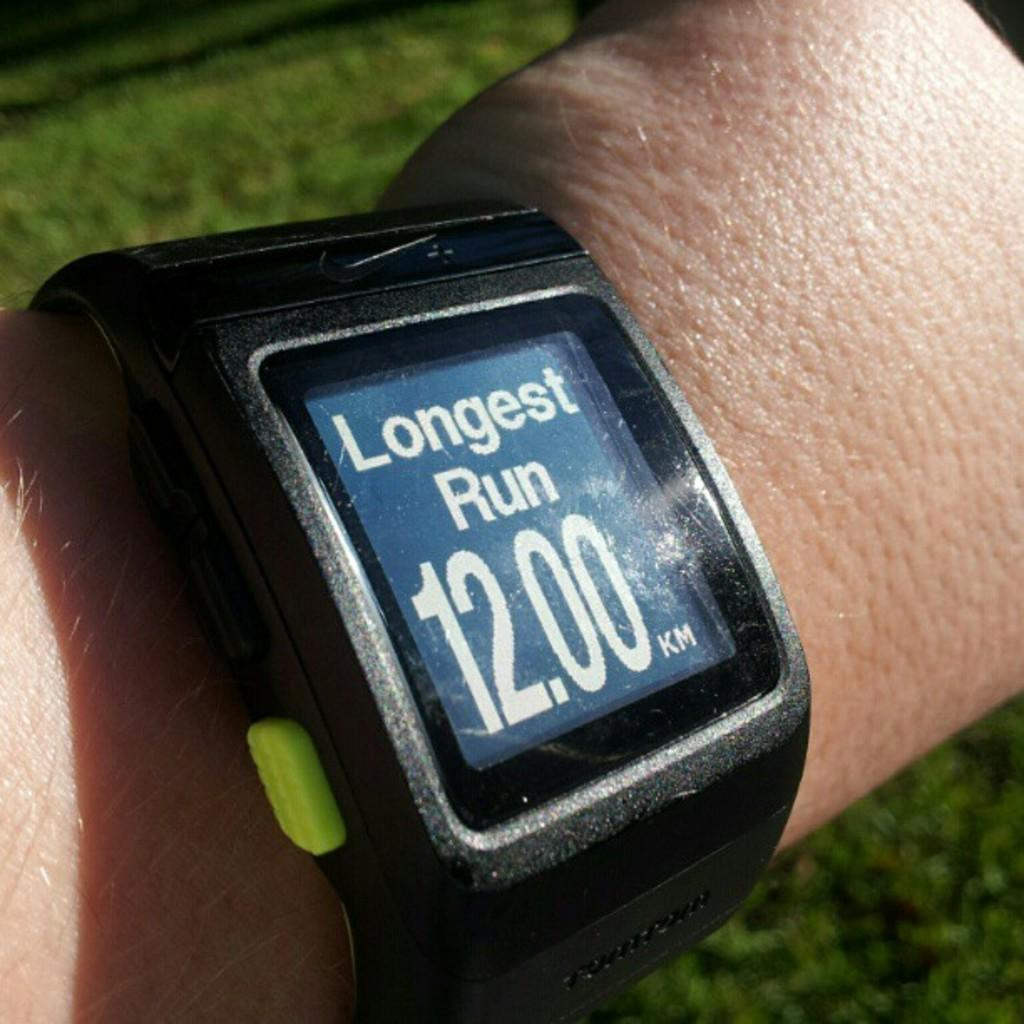<image>
Write a terse but informative summary of the picture. A fitness tracker on a wrist and on the screen it says Longest Run 12.00km 